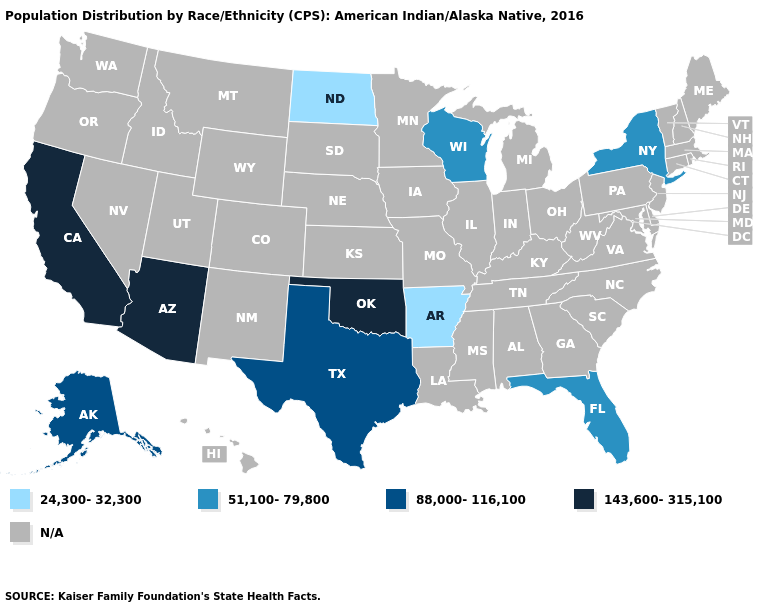Name the states that have a value in the range N/A?
Give a very brief answer. Alabama, Colorado, Connecticut, Delaware, Georgia, Hawaii, Idaho, Illinois, Indiana, Iowa, Kansas, Kentucky, Louisiana, Maine, Maryland, Massachusetts, Michigan, Minnesota, Mississippi, Missouri, Montana, Nebraska, Nevada, New Hampshire, New Jersey, New Mexico, North Carolina, Ohio, Oregon, Pennsylvania, Rhode Island, South Carolina, South Dakota, Tennessee, Utah, Vermont, Virginia, Washington, West Virginia, Wyoming. Which states have the highest value in the USA?
Short answer required. Arizona, California, Oklahoma. What is the value of Rhode Island?
Concise answer only. N/A. What is the value of Georgia?
Give a very brief answer. N/A. Name the states that have a value in the range 51,100-79,800?
Keep it brief. Florida, New York, Wisconsin. Which states have the highest value in the USA?
Concise answer only. Arizona, California, Oklahoma. What is the value of Georgia?
Concise answer only. N/A. What is the lowest value in the USA?
Concise answer only. 24,300-32,300. What is the value of Maine?
Short answer required. N/A. Name the states that have a value in the range N/A?
Give a very brief answer. Alabama, Colorado, Connecticut, Delaware, Georgia, Hawaii, Idaho, Illinois, Indiana, Iowa, Kansas, Kentucky, Louisiana, Maine, Maryland, Massachusetts, Michigan, Minnesota, Mississippi, Missouri, Montana, Nebraska, Nevada, New Hampshire, New Jersey, New Mexico, North Carolina, Ohio, Oregon, Pennsylvania, Rhode Island, South Carolina, South Dakota, Tennessee, Utah, Vermont, Virginia, Washington, West Virginia, Wyoming. 